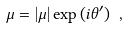Convert formula to latex. <formula><loc_0><loc_0><loc_500><loc_500>\mu = | \mu | \exp { ( i \theta ^ { \prime } ) } \ ,</formula> 